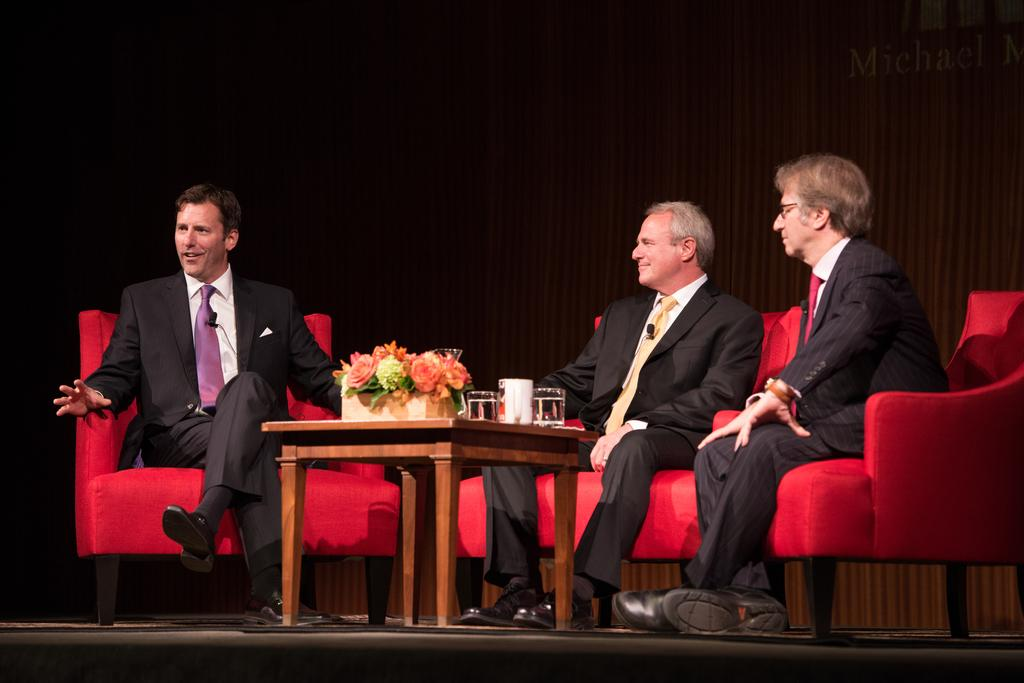How many men are in the image? There are three men in the image. What are the men doing in the image? The men are sitting on chairs. What is present on the table in the image? There is a flower vase and glasses on the table. What can be seen in the background of the image? There is a curtain in the background of the image. What type of coil can be seen on the table in the image? There is no coil present on the table in the image. Can you tell me how many cows are in the image? There are no cows present in the image. 